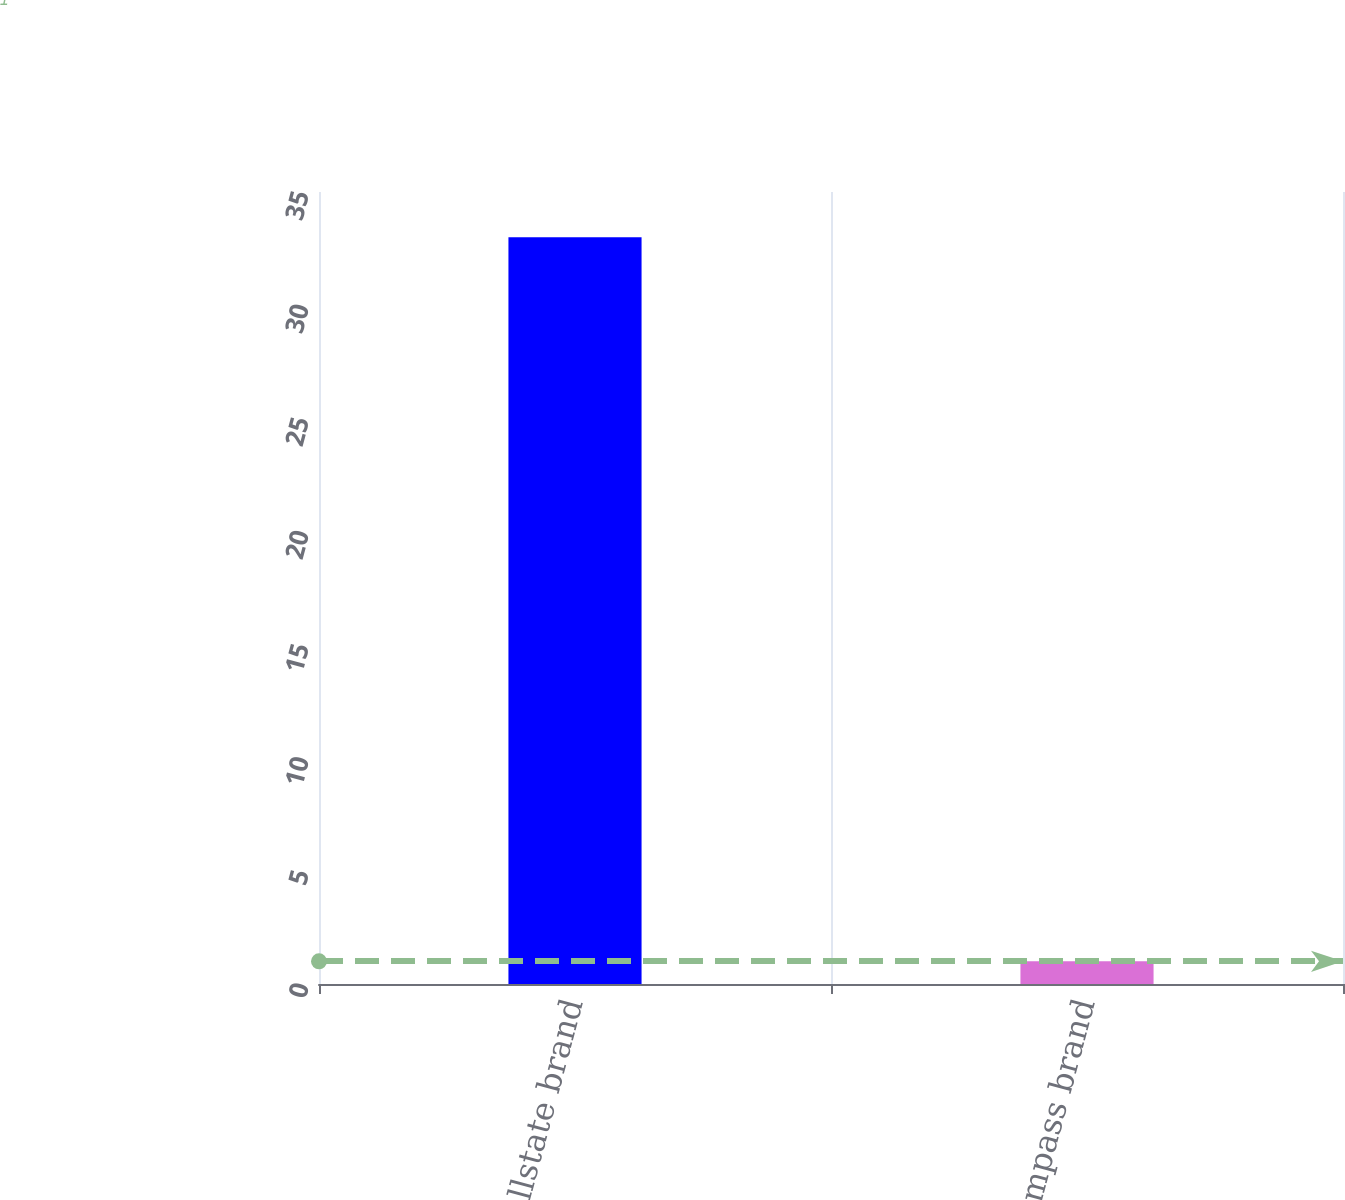Convert chart. <chart><loc_0><loc_0><loc_500><loc_500><bar_chart><fcel>Allstate brand<fcel>Encompass brand<nl><fcel>33<fcel>1<nl></chart> 